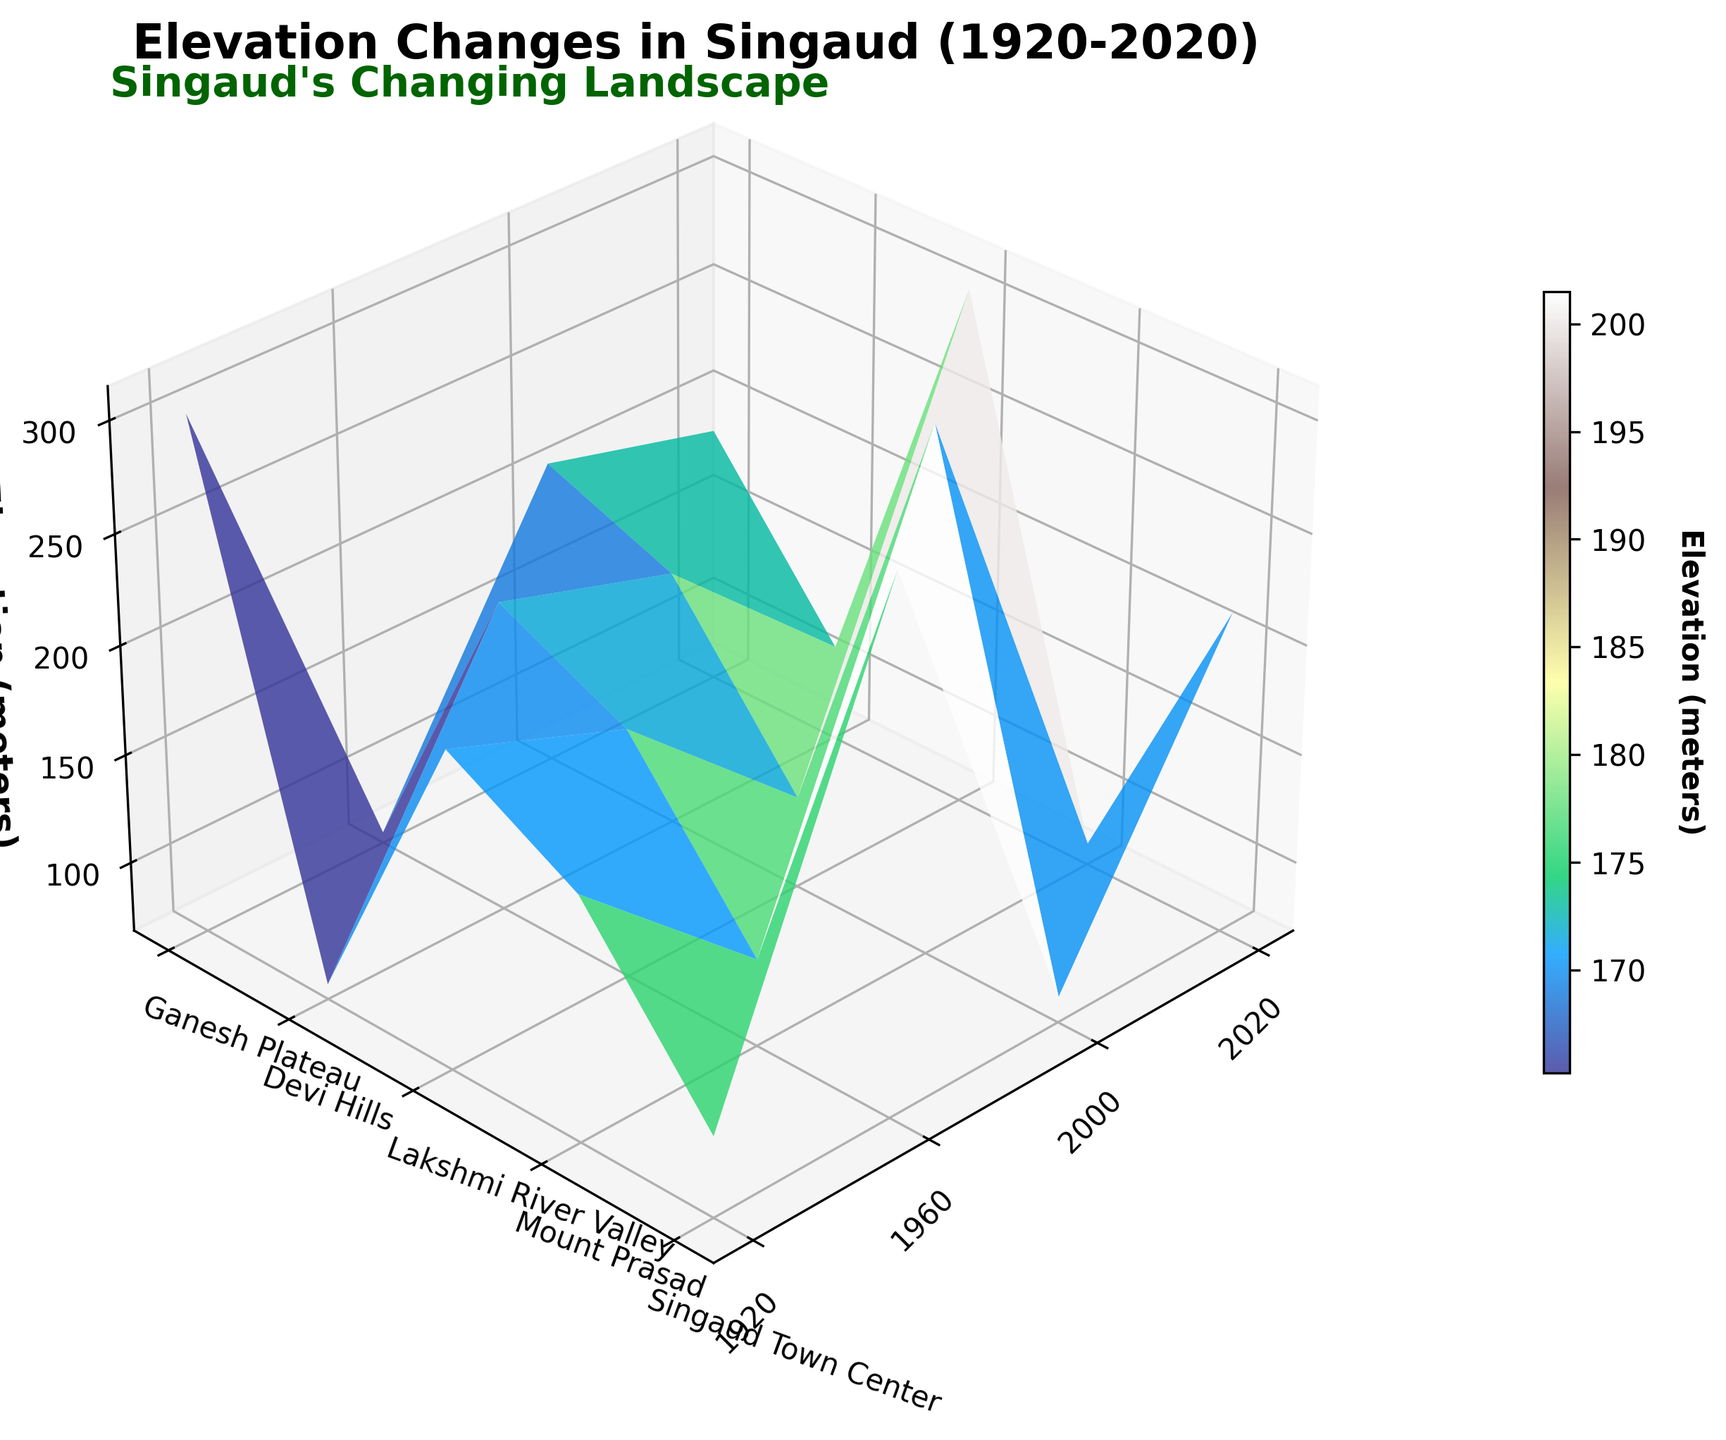What is the title of the figure? The title of the figure can be found at the top, it is designed to give an overview of the plot's content.
Answer: Elevation Changes in Singaud (1920-2020) What are the years mentioned on the x-axis? The x-axis ticks label the years and give the timeframe of the data being visualized. Based on the labels, we can list the specific years shown.
Answer: 1920, 1960, 2000, 2020 Which location had the highest elevation in 2020? By observing the elevation values along the z-axis for the year 2020, we can compare the elevations of different locations and find the highest one.
Answer: Mount Prasad How does the elevation of Singaud Town Center change from 1920 to 2020? The changes in the elevation over the years can be tracked along the x-axis for Singaud Town Center, analyzing the z-axis values for each corresponding year.
Answer: It increased from 105 meters in 1920 to 112 meters in 2020 Which location shows the largest decrease in elevation from 1920 to 2020? To determine this, compare the elevation values in 1920 and 2020 for each location, focusing on the difference in elevation for each.
Answer: Mount Prasad What is the average elevation of Devi Hills over the entire period? First, determine the elevation values of Devi Hills at all the given years, then sum them up and divide by the number of years to find the average.
Answer: 211.5 meters Which location had the lowest elevation in 1920? By looking at the elevation values along the z-axis for the year 1920 and comparing the values, we can find which location has the minimum elevation.
Answer: Lakshmi River Valley How does the elevation trend of Ganesh Plateau compare with Singaud Town Center over the years? To compare the trends, observe the elevation values of both locations over the different years and analyze the patterns of increase or decrease.
Answer: Ganesh Plateau's elevation has a slight increase, while Singaud Town Center shows a more consistent and larger increase Which location had the constant or least varying elevation over the years? Identify the variations in the elevation values for each location over the years and find the location with the smallest difference between the highest and lowest elevations.
Answer: Devi Hills How are the changes in Lakshmi River Valley's elevation depicted on the plot's surface? Look at the surface's color gradient and contour changes specifically for Lakshmi River Valley over different years to understand how the elevation varies.
Answer: It shows a decreasing trend from 80 meters in 1920 to 73 meters in 2020 